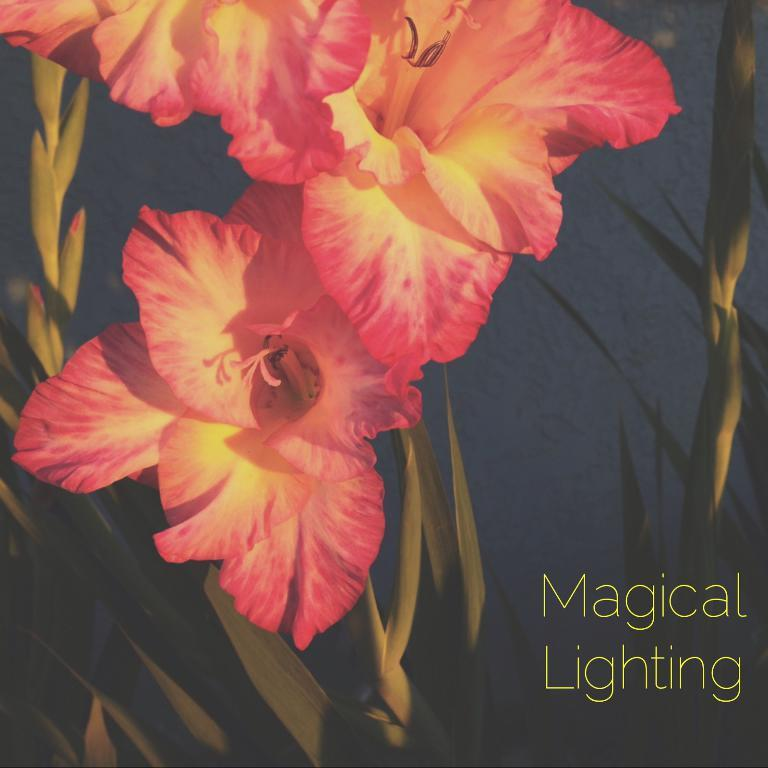What colors are the flowers in the image? There are pink and yellow flowers in the image. What else can be observed about the flowers? The flowers have leaves. Is there any text or writing in the image? Yes, there is text or writing in the right corner of the image. How does the girl feel about the weather in the image? There is no girl present in the image, so it is not possible to determine her feelings about the weather. 